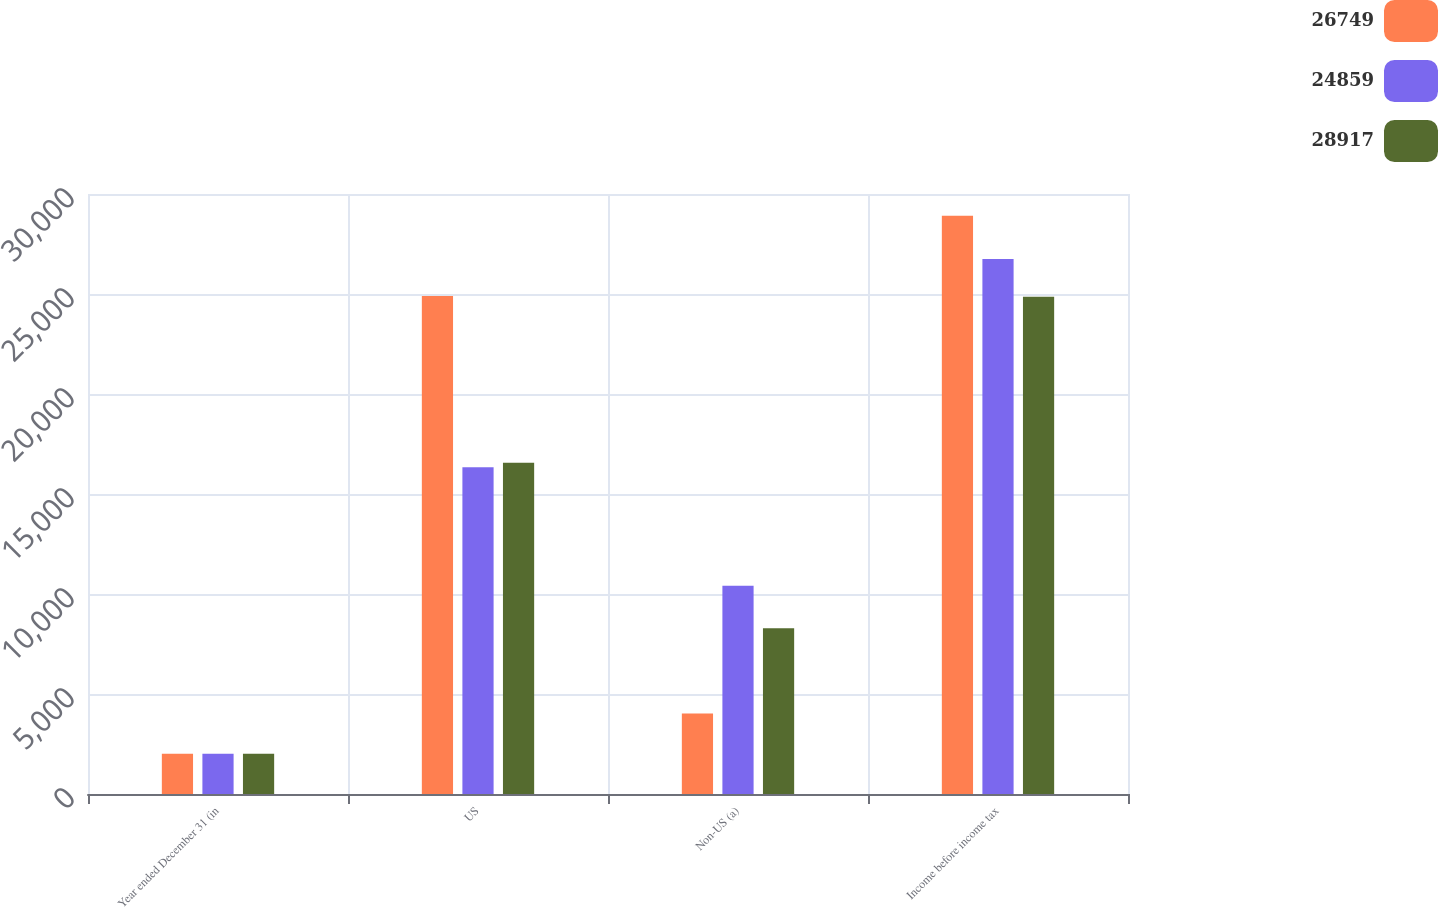Convert chart. <chart><loc_0><loc_0><loc_500><loc_500><stacked_bar_chart><ecel><fcel>Year ended December 31 (in<fcel>US<fcel>Non-US (a)<fcel>Income before income tax<nl><fcel>26749<fcel>2012<fcel>24895<fcel>4022<fcel>28917<nl><fcel>24859<fcel>2011<fcel>16336<fcel>10413<fcel>26749<nl><fcel>28917<fcel>2010<fcel>16568<fcel>8291<fcel>24859<nl></chart> 